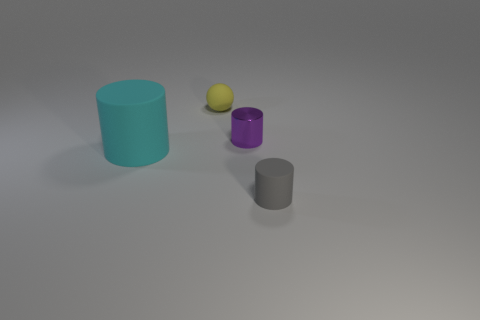Add 1 tiny rubber cylinders. How many objects exist? 5 Subtract all cylinders. How many objects are left? 1 Add 1 big cylinders. How many big cylinders are left? 2 Add 1 tiny metal things. How many tiny metal things exist? 2 Subtract 0 brown blocks. How many objects are left? 4 Subtract all tiny cyan objects. Subtract all big cyan cylinders. How many objects are left? 3 